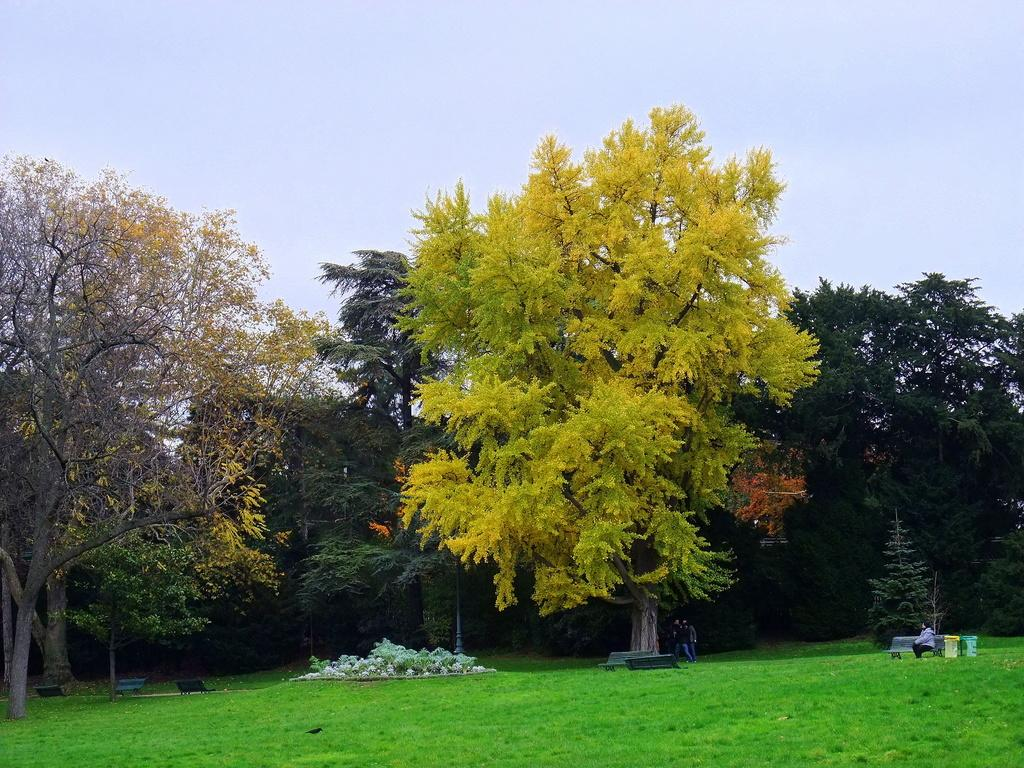What type of surface is on the ground in the image? There is grass on the ground in the image. What is the person in the image doing? There is a person sitting on a bench in the image. What can be seen in the middle of the image? There are trees in the middle of the image. What is visible at the top of the image? The sky is visible at the top of the image. How many bulbs are hanging from the trees in the image? There are no bulbs present in the image; it features trees without any lighting fixtures. What type of nerve is visible in the person's hand in the image? There is no nerve visible in the person's hand in the image; it is not possible to see internal body structures in this context. 